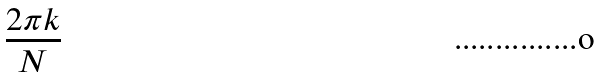Convert formula to latex. <formula><loc_0><loc_0><loc_500><loc_500>\frac { 2 \pi k } { N }</formula> 